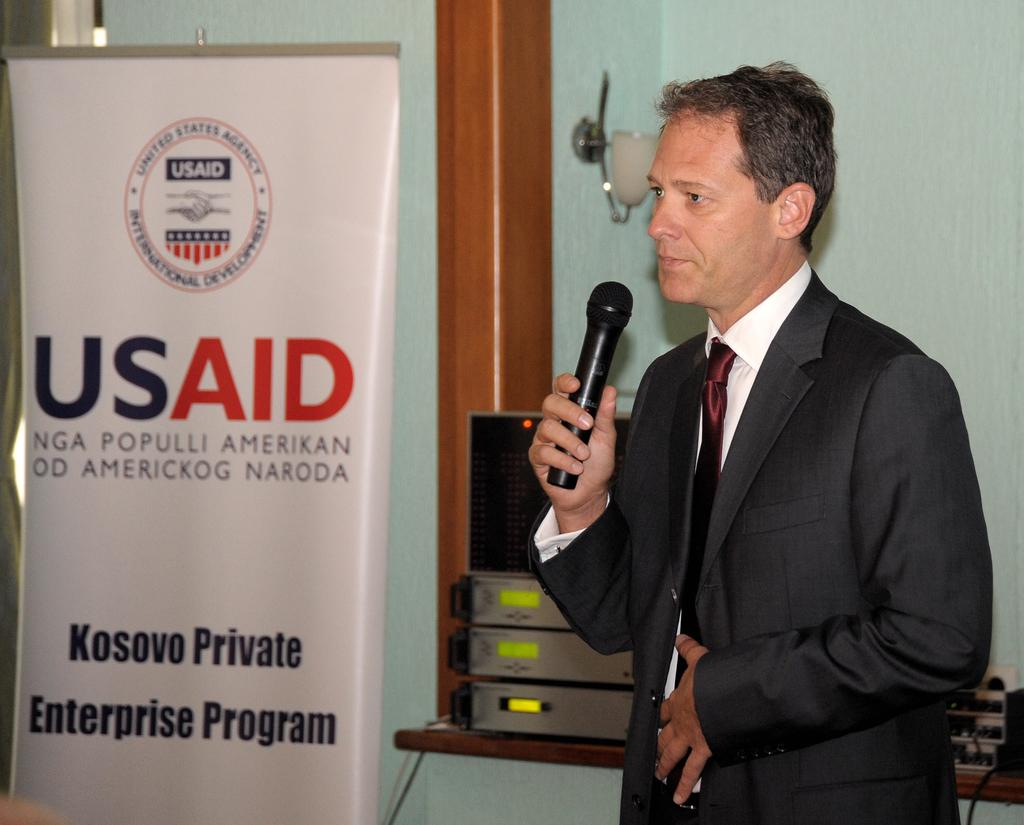What is the man in the image holding? The man is holding a microphone. What is the man wearing in the image? The man is wearing a suit. What can be seen in the background of the image? There is a wall and electronic devices in the background of the image. What is present in the image that might be used for displaying information or advertising? There is a banner in the image. What type of tooth is visible on the man's suit in the image? There is no tooth visible on the man's suit in the image. What color is the dress worn by the man in the image? The man is not wearing a dress in the image; he is wearing a suit. 